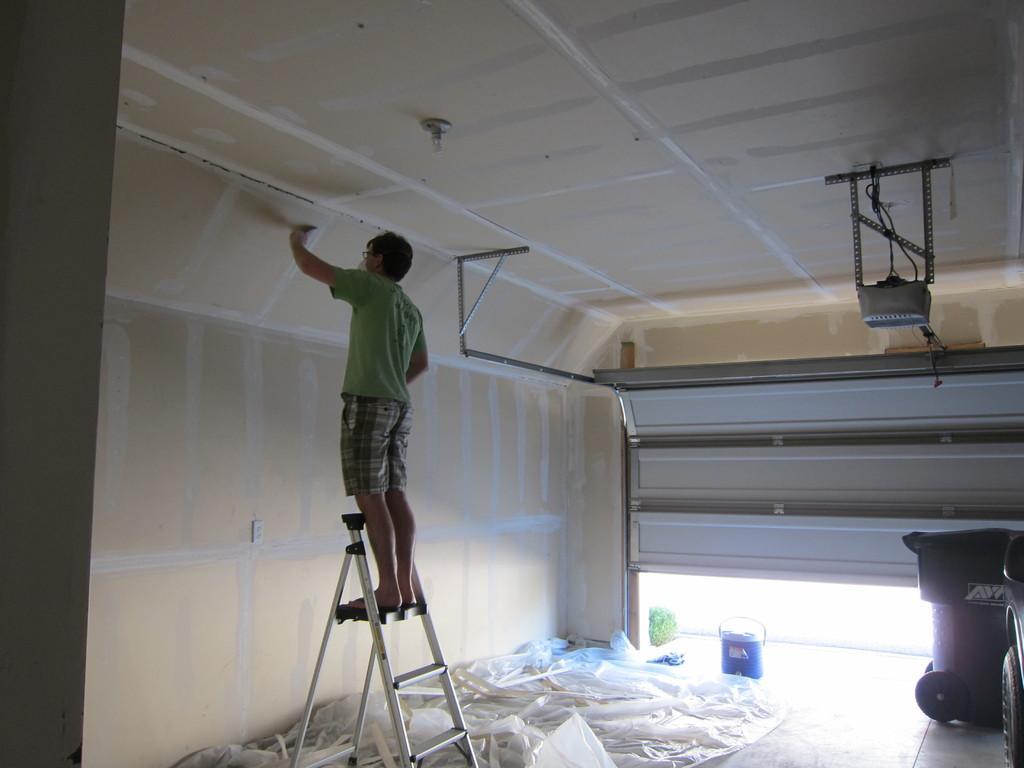Please provide a concise description of this image. In this image there is one person standing on the ladder as we can see on the left side of this image. There is a wall in the background. There is a shutter on the right side of this image. There is a cover on the floor as we can see in the bottom of this image. There is one object is in the bottom right corner of this image. 